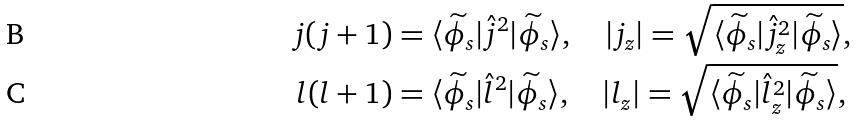Convert formula to latex. <formula><loc_0><loc_0><loc_500><loc_500>j ( j + 1 ) & = \langle \widetilde { \phi } _ { s } | \hat { j } ^ { 2 } | \widetilde { \phi } _ { s } \rangle , \quad | j _ { z } | = \sqrt { \langle \widetilde { \phi } _ { s } | \hat { j } _ { z } ^ { 2 } | \widetilde { \phi } _ { s } \rangle } , \\ l ( l + 1 ) & = \langle \widetilde { \phi } _ { s } | \hat { l } ^ { 2 } | \widetilde { \phi } _ { s } \rangle , \quad | l _ { z } | = \sqrt { \langle \widetilde { \phi } _ { s } | \hat { l } _ { z } ^ { 2 } | \widetilde { \phi } _ { s } \rangle } ,</formula> 